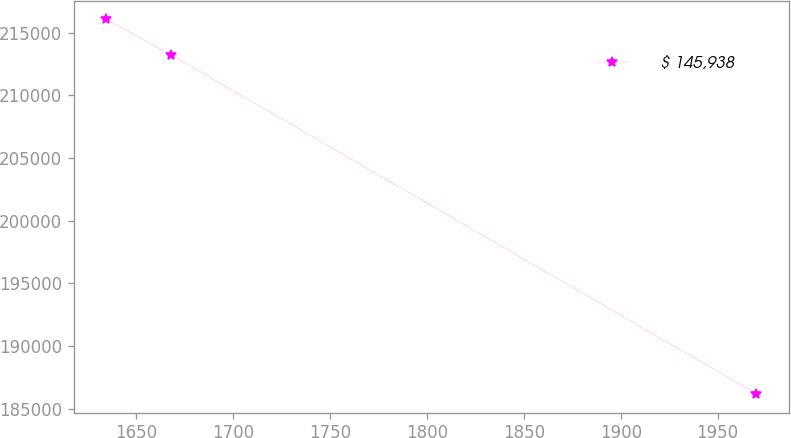Convert chart to OTSL. <chart><loc_0><loc_0><loc_500><loc_500><line_chart><ecel><fcel>$ 145,938<nl><fcel>1634.56<fcel>216064<nl><fcel>1668.11<fcel>213225<nl><fcel>1970.03<fcel>186173<nl></chart> 